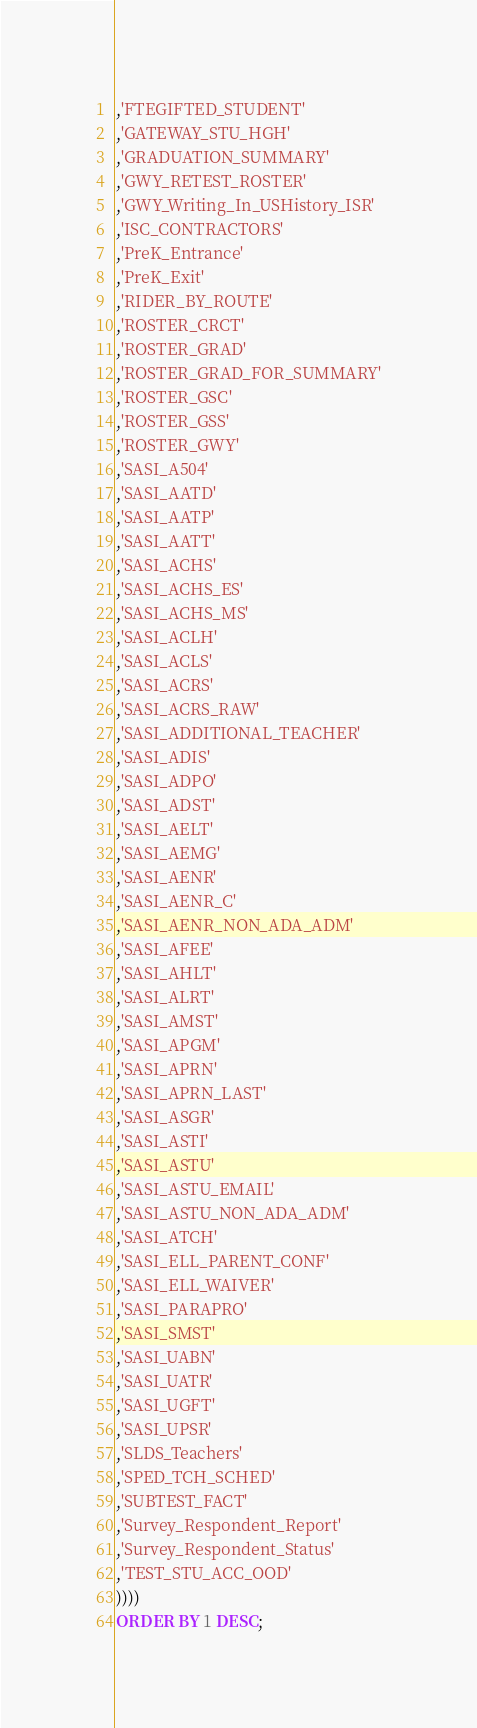<code> <loc_0><loc_0><loc_500><loc_500><_SQL_>,'FTEGIFTED_STUDENT'
,'GATEWAY_STU_HGH'
,'GRADUATION_SUMMARY'
,'GWY_RETEST_ROSTER'
,'GWY_Writing_In_USHistory_ISR'
,'ISC_CONTRACTORS'
,'PreK_Entrance'
,'PreK_Exit'
,'RIDER_BY_ROUTE'
,'ROSTER_CRCT'
,'ROSTER_GRAD'
,'ROSTER_GRAD_FOR_SUMMARY'
,'ROSTER_GSC'
,'ROSTER_GSS'
,'ROSTER_GWY'
,'SASI_A504'
,'SASI_AATD'
,'SASI_AATP'
,'SASI_AATT'
,'SASI_ACHS'
,'SASI_ACHS_ES'
,'SASI_ACHS_MS'
,'SASI_ACLH'
,'SASI_ACLS'
,'SASI_ACRS'
,'SASI_ACRS_RAW'
,'SASI_ADDITIONAL_TEACHER'
,'SASI_ADIS'
,'SASI_ADPO'
,'SASI_ADST'
,'SASI_AELT'
,'SASI_AEMG'
,'SASI_AENR'
,'SASI_AENR_C'
,'SASI_AENR_NON_ADA_ADM'
,'SASI_AFEE'
,'SASI_AHLT'
,'SASI_ALRT'
,'SASI_AMST'
,'SASI_APGM'
,'SASI_APRN'
,'SASI_APRN_LAST'
,'SASI_ASGR'
,'SASI_ASTI'
,'SASI_ASTU'
,'SASI_ASTU_EMAIL'
,'SASI_ASTU_NON_ADA_ADM'
,'SASI_ATCH'
,'SASI_ELL_PARENT_CONF'
,'SASI_ELL_WAIVER'
,'SASI_PARAPRO'
,'SASI_SMST'
,'SASI_UABN'
,'SASI_UATR'
,'SASI_UGFT'
,'SASI_UPSR'
,'SLDS_Teachers'
,'SPED_TCH_SCHED'
,'SUBTEST_FACT'
,'Survey_Respondent_Report'
,'Survey_Respondent_Status'
,'TEST_STU_ACC_OOD'
))))
ORDER BY 1 DESC;</code> 